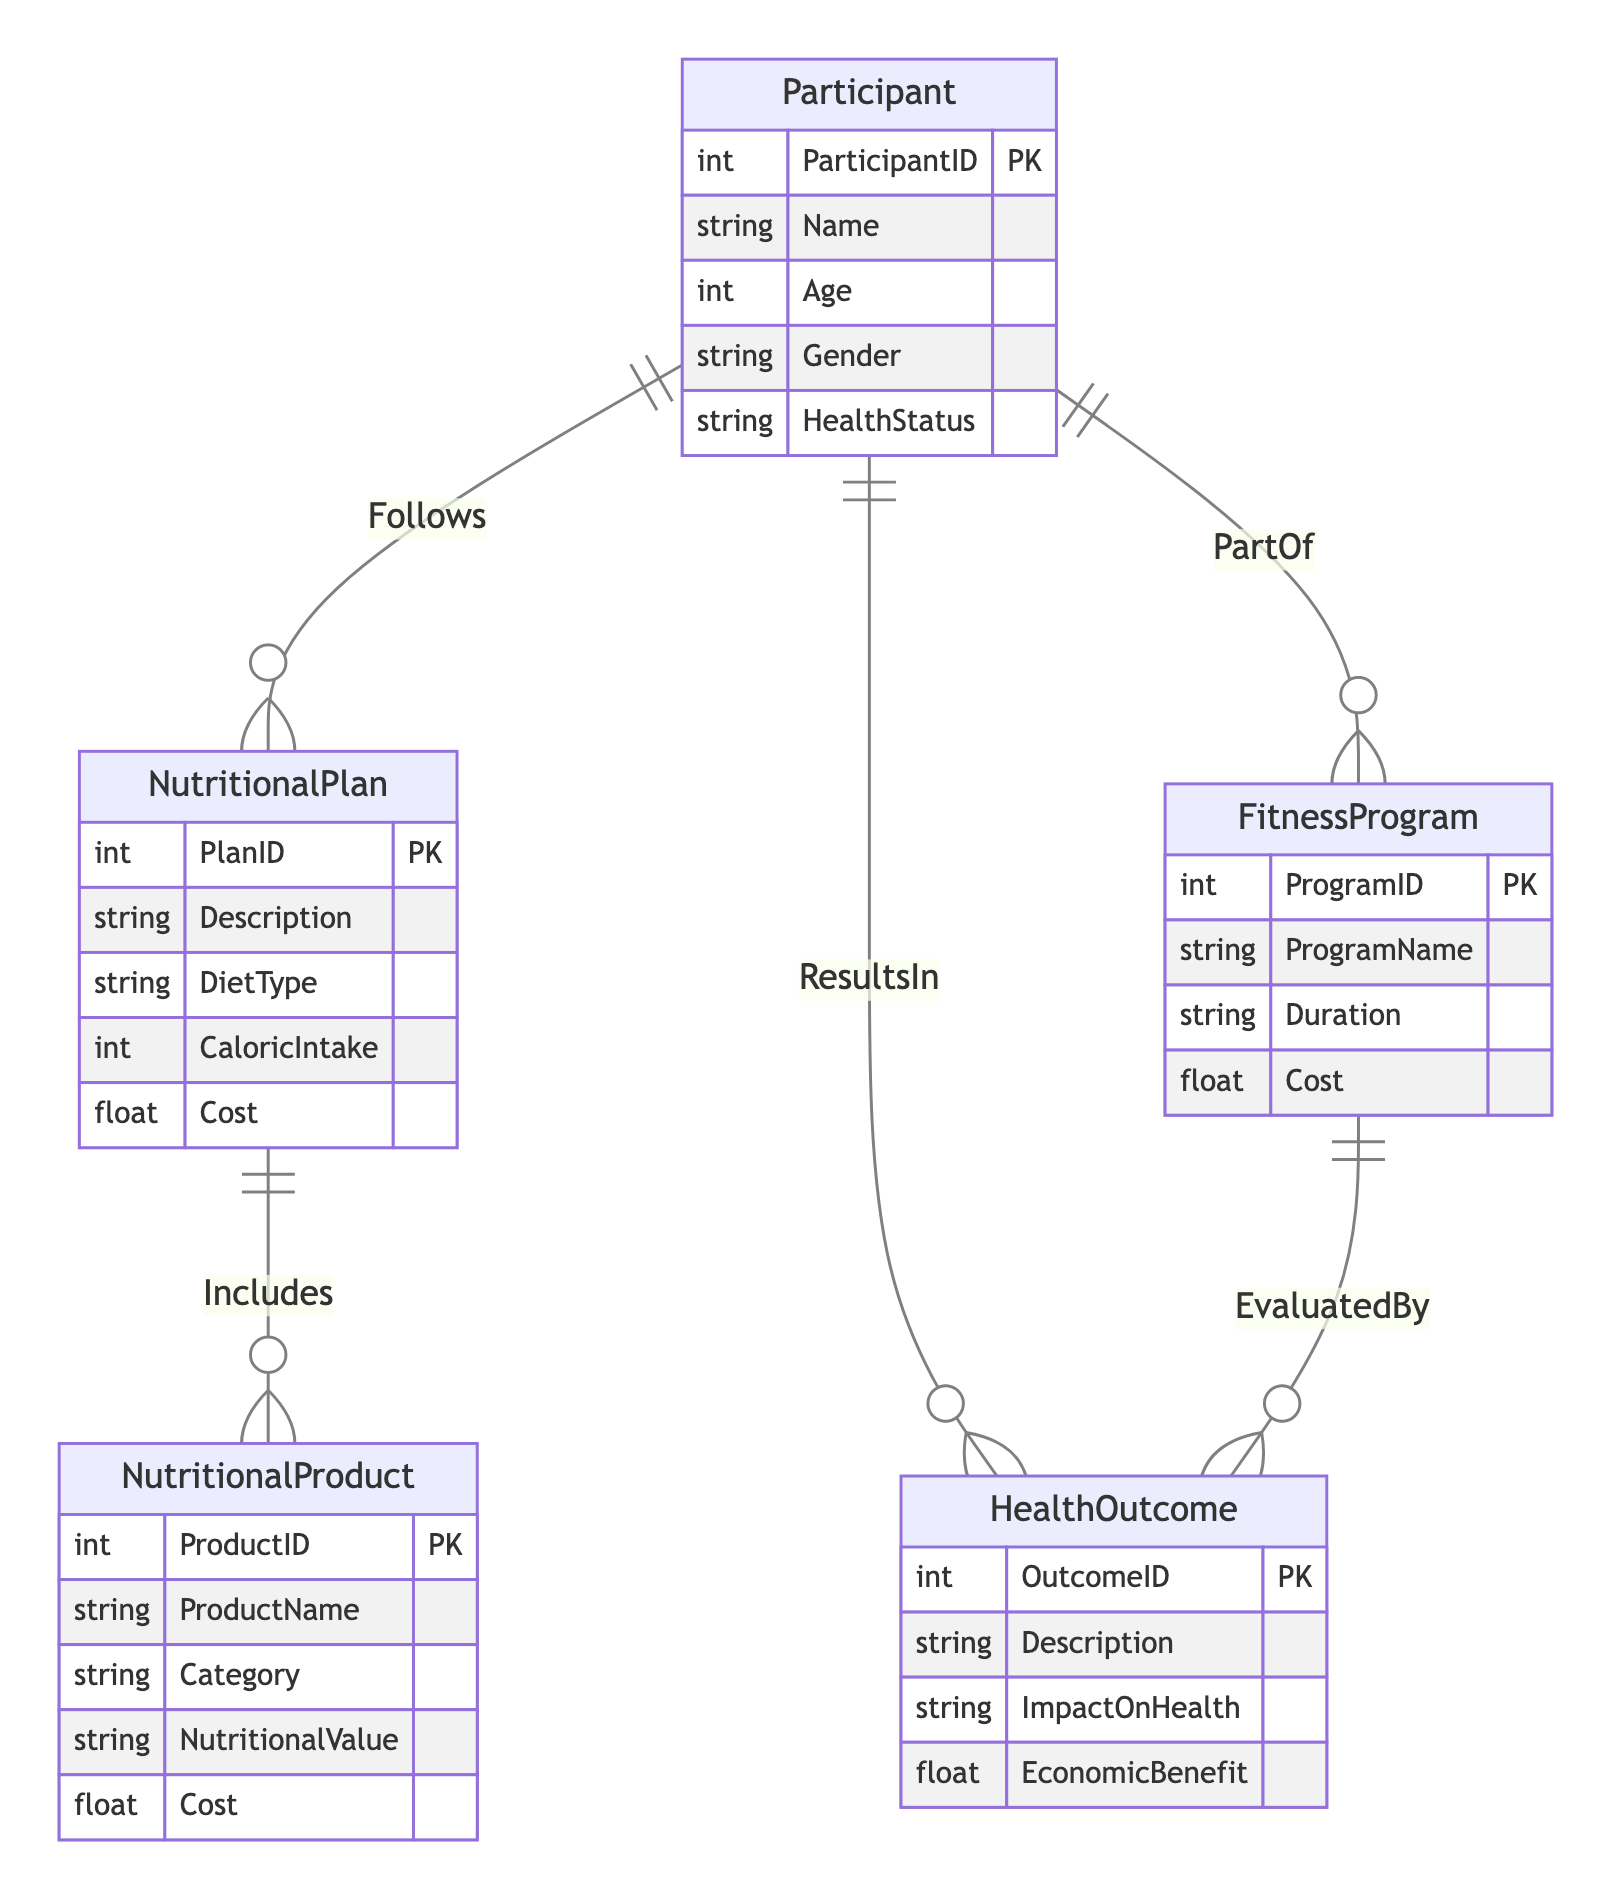What is the primary key of the Participant entity? The primary key of the Participant entity is ParticipantID, which uniquely identifies each participant in the diagram.
Answer: ParticipantID How many attributes does the NutritionalPlan entity have? The NutritionalPlan entity has five attributes listed in the diagram: PlanID, Description, DietType, CaloricIntake, and Cost.
Answer: 5 Which entity has a relationship labeled "Follows"? The "Follows" relationship is between the Participant and NutritionalPlan entities, indicating that participants adhere to specific nutritional plans.
Answer: NutritionalPlan What is the relationship between FitnessProgram and HealthOutcome? The relationship between FitnessProgram and HealthOutcome is labeled "EvaluatedBy," signifying that the health outcomes are assessed based on the fitness programs.
Answer: EvaluatedBy How many entities are there in the diagram? The diagram contains five entities: Participant, NutritionalPlan, NutritionalProduct, FitnessProgram, and HealthOutcome.
Answer: 5 Which entity directly relates to health outcomes based on the participant’s nutrition? The NutritionalPlan entity directly relates to health outcomes through the Participant, as the nutritional plan followed by participants impacts their health outcomes.
Answer: NutritionalPlan If a participant follows a nutritional plan, what can be inferred about their dietary choices? If a participant follows a nutritional plan, it implies that their dietary choices are structured according to that plan's description, diet type, and caloric intake.
Answer: Structured dietary choices What is the relationship between NutritionalPlan and NutritionalProduct? The relationship between NutritionalPlan and NutritionalProduct is labeled "Includes," indicating that nutritional plans consist of various nutritional products.
Answer: Includes Which attribute connects a nutritional product to its cost? The attribute that connects a nutritional product to its cost is Cost, which specifies the monetary expense associated with each nutritional product.
Answer: Cost 